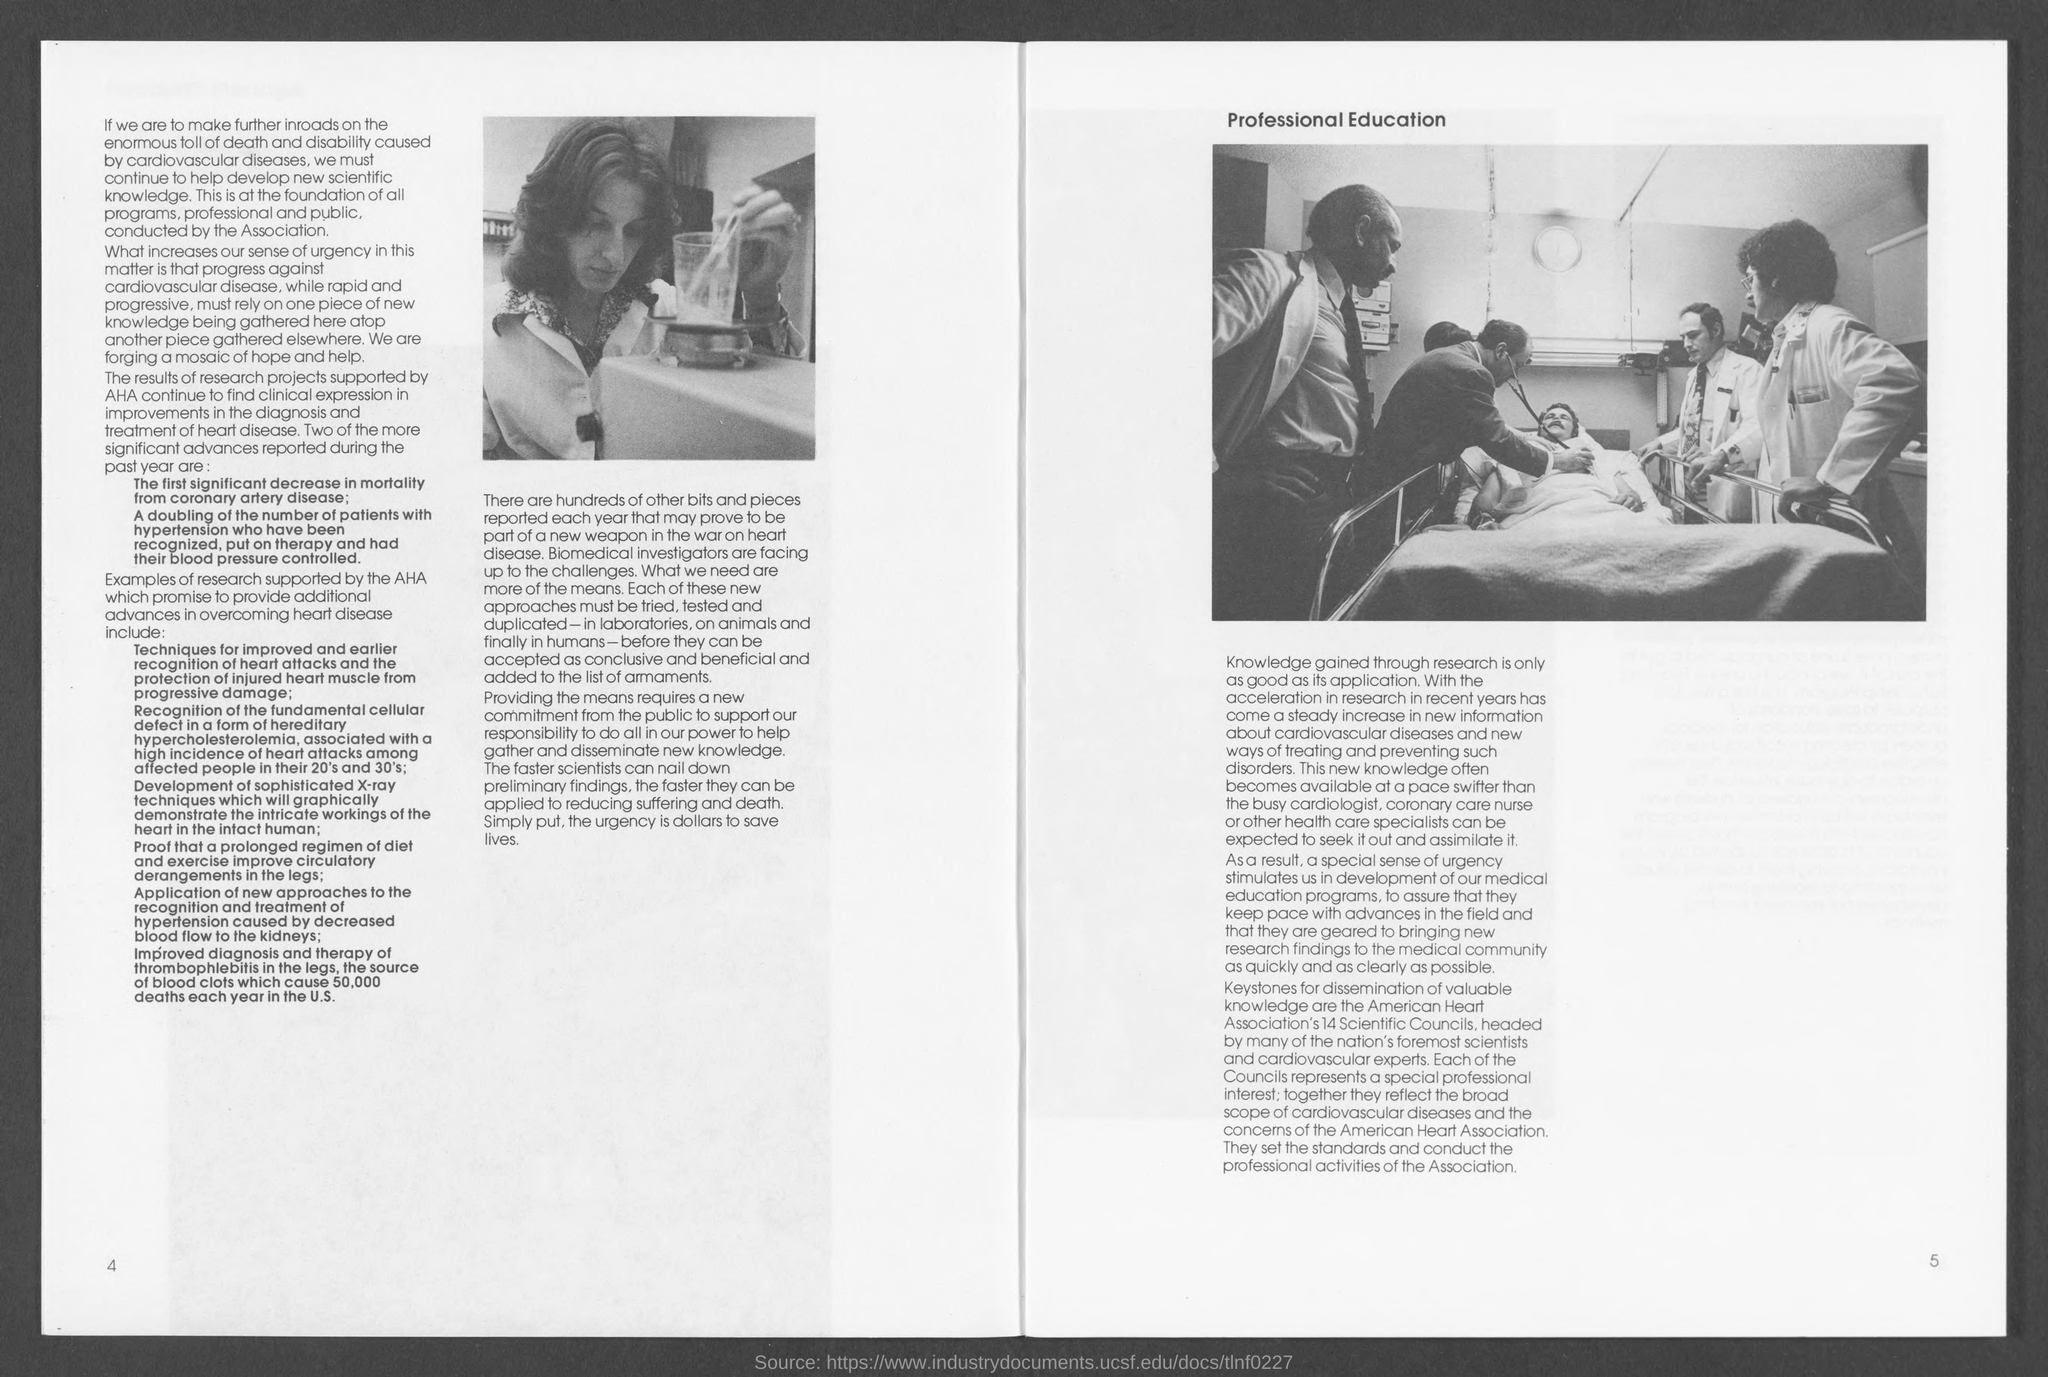What is the disease mentioned in the first paragraph?
Provide a succinct answer. Cardiovascular. 